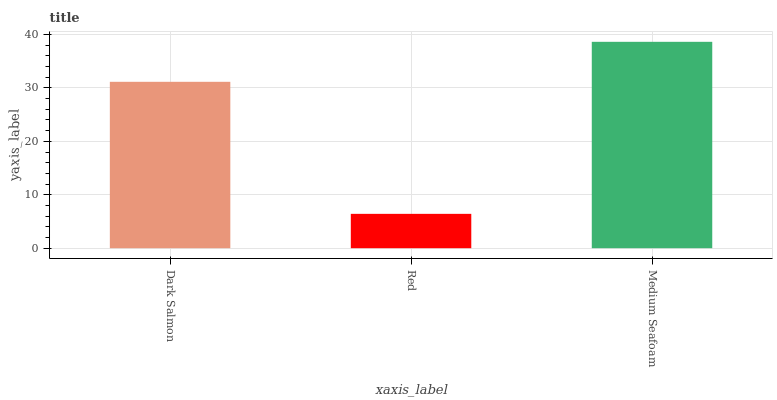Is Red the minimum?
Answer yes or no. Yes. Is Medium Seafoam the maximum?
Answer yes or no. Yes. Is Medium Seafoam the minimum?
Answer yes or no. No. Is Red the maximum?
Answer yes or no. No. Is Medium Seafoam greater than Red?
Answer yes or no. Yes. Is Red less than Medium Seafoam?
Answer yes or no. Yes. Is Red greater than Medium Seafoam?
Answer yes or no. No. Is Medium Seafoam less than Red?
Answer yes or no. No. Is Dark Salmon the high median?
Answer yes or no. Yes. Is Dark Salmon the low median?
Answer yes or no. Yes. Is Red the high median?
Answer yes or no. No. Is Red the low median?
Answer yes or no. No. 